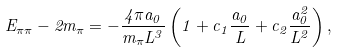Convert formula to latex. <formula><loc_0><loc_0><loc_500><loc_500>E _ { \pi \pi } - 2 m _ { \pi } = - \frac { 4 \pi a _ { 0 } } { m _ { \pi } L ^ { 3 } } \left ( 1 + c _ { 1 } \frac { a _ { 0 } } { L } + c _ { 2 } \frac { a _ { 0 } ^ { 2 } } { L ^ { 2 } } \right ) ,</formula> 